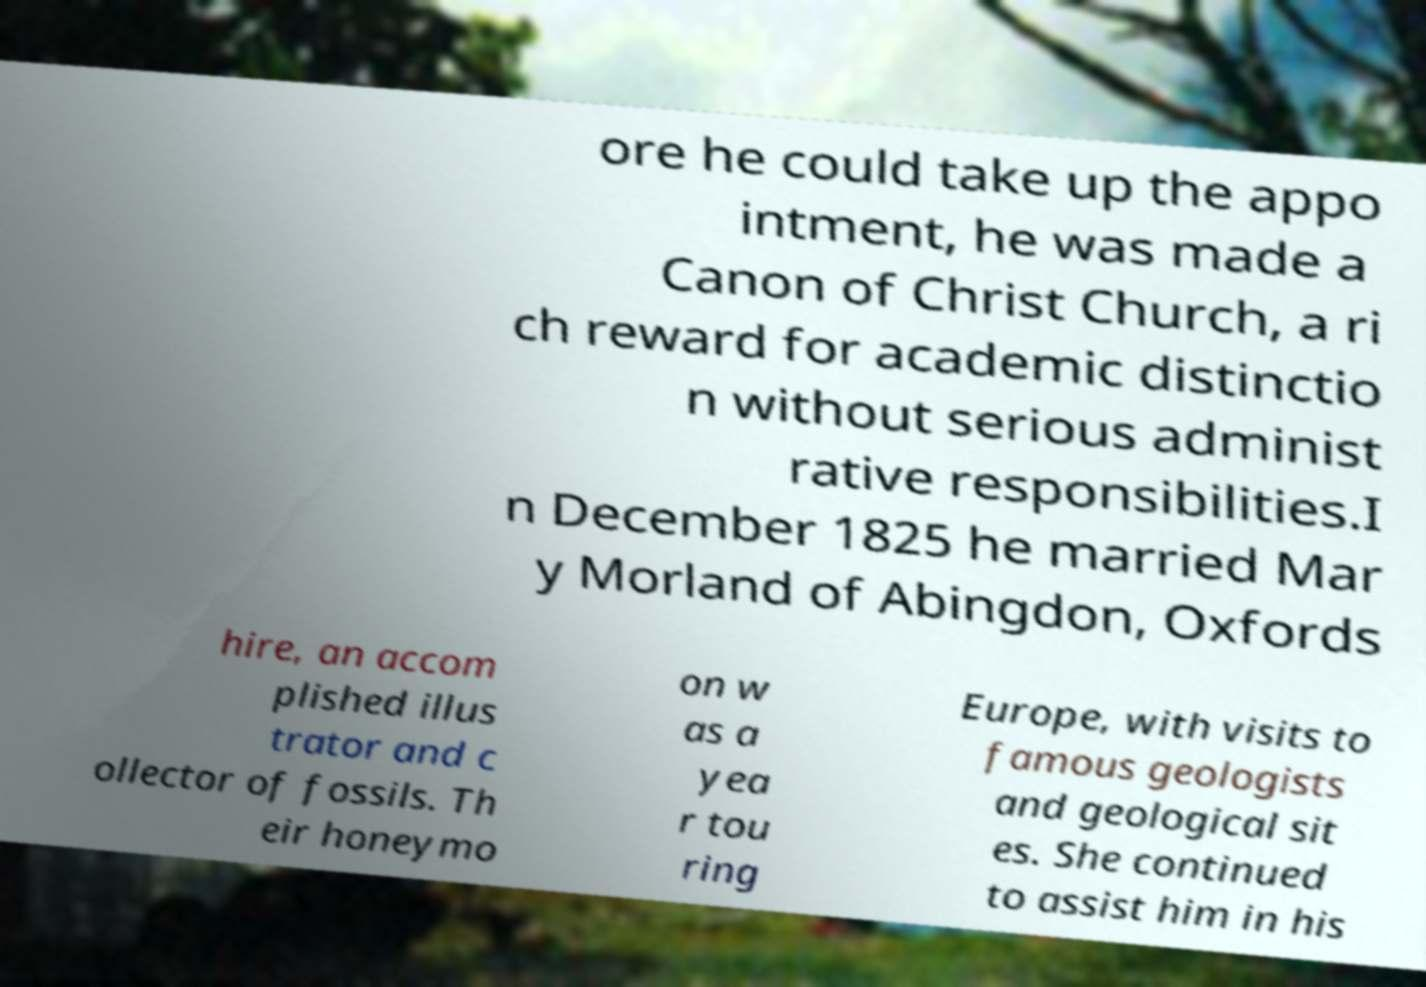Can you read and provide the text displayed in the image?This photo seems to have some interesting text. Can you extract and type it out for me? ore he could take up the appo intment, he was made a Canon of Christ Church, a ri ch reward for academic distinctio n without serious administ rative responsibilities.I n December 1825 he married Mar y Morland of Abingdon, Oxfords hire, an accom plished illus trator and c ollector of fossils. Th eir honeymo on w as a yea r tou ring Europe, with visits to famous geologists and geological sit es. She continued to assist him in his 